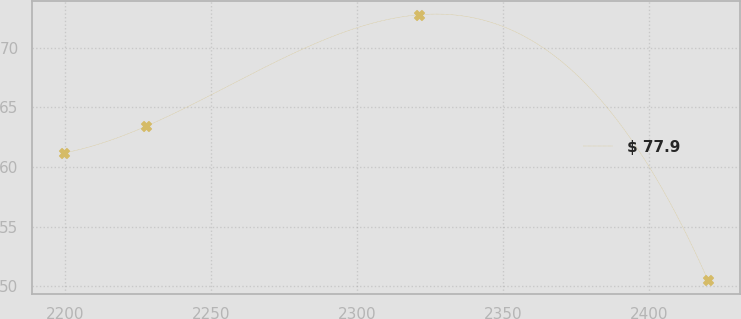Convert chart to OTSL. <chart><loc_0><loc_0><loc_500><loc_500><line_chart><ecel><fcel>$ 77.9<nl><fcel>2199.68<fcel>61.18<nl><fcel>2227.72<fcel>63.41<nl><fcel>2321.32<fcel>72.78<nl><fcel>2420.18<fcel>50.49<nl></chart> 